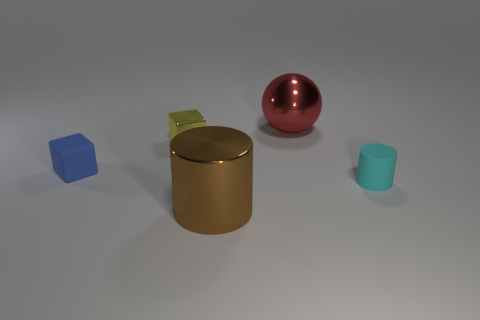Add 5 small blue metal things. How many objects exist? 10 Subtract all cylinders. How many objects are left? 3 Subtract all cyan rubber things. Subtract all big red rubber cylinders. How many objects are left? 4 Add 4 brown things. How many brown things are left? 5 Add 4 big red rubber cylinders. How many big red rubber cylinders exist? 4 Subtract 0 cyan cubes. How many objects are left? 5 Subtract all brown cylinders. Subtract all gray blocks. How many cylinders are left? 1 Subtract all cyan cubes. How many cyan cylinders are left? 1 